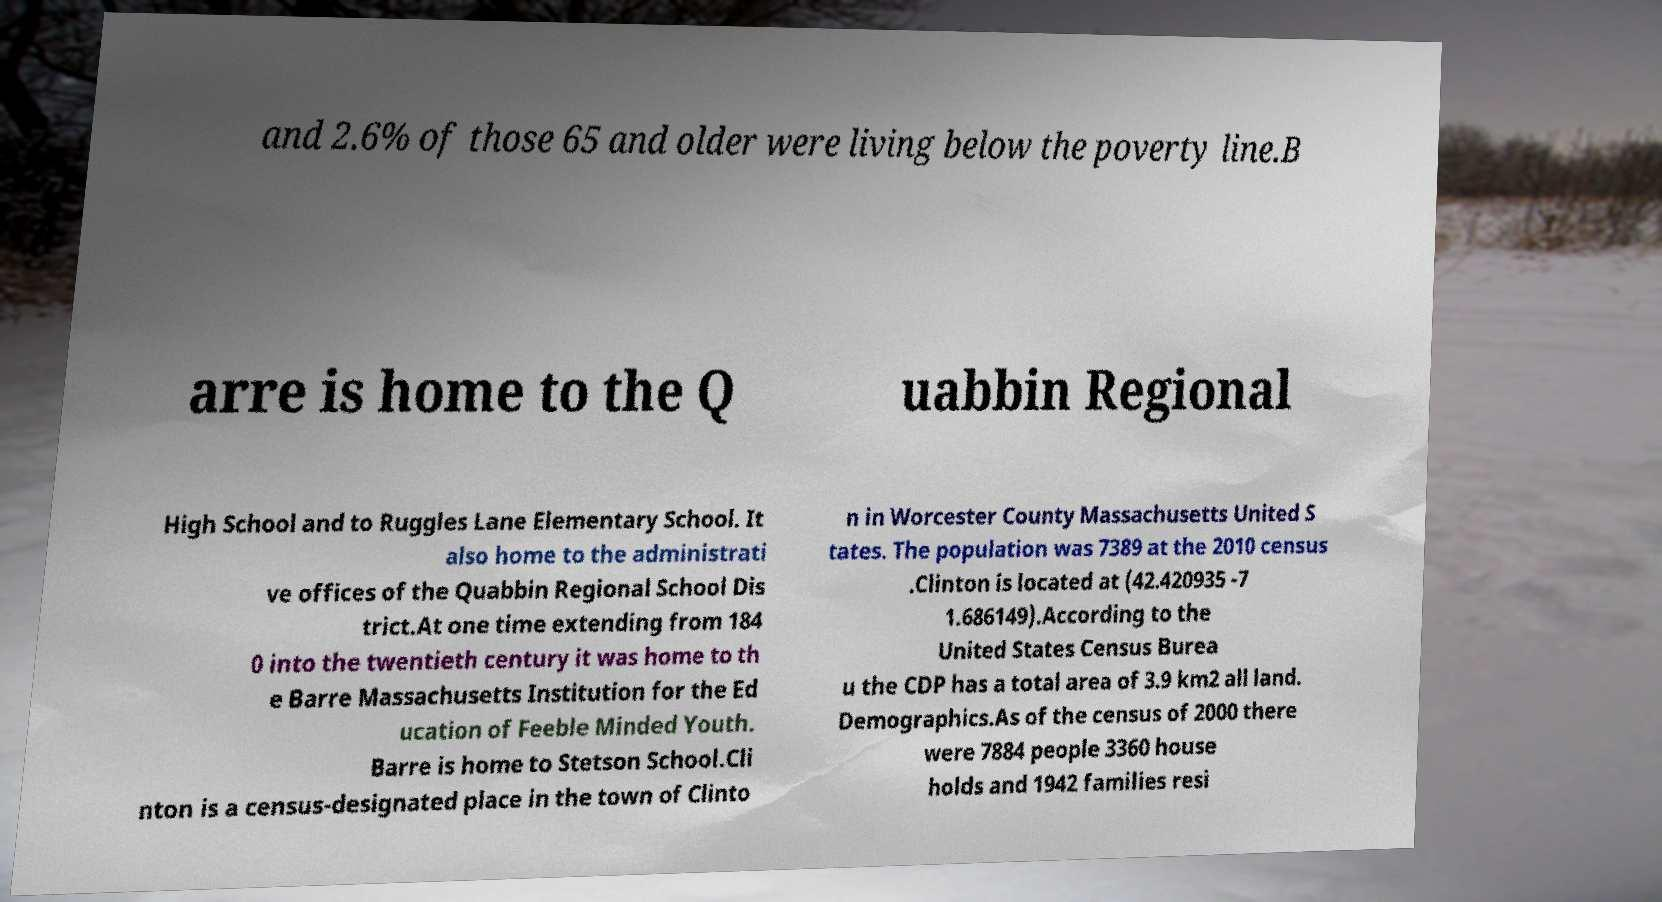I need the written content from this picture converted into text. Can you do that? and 2.6% of those 65 and older were living below the poverty line.B arre is home to the Q uabbin Regional High School and to Ruggles Lane Elementary School. It also home to the administrati ve offices of the Quabbin Regional School Dis trict.At one time extending from 184 0 into the twentieth century it was home to th e Barre Massachusetts Institution for the Ed ucation of Feeble Minded Youth. Barre is home to Stetson School.Cli nton is a census-designated place in the town of Clinto n in Worcester County Massachusetts United S tates. The population was 7389 at the 2010 census .Clinton is located at (42.420935 -7 1.686149).According to the United States Census Burea u the CDP has a total area of 3.9 km2 all land. Demographics.As of the census of 2000 there were 7884 people 3360 house holds and 1942 families resi 